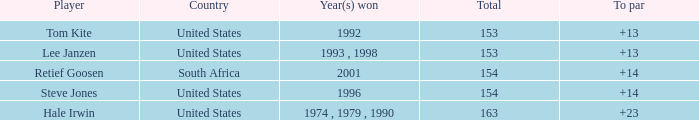What is the highest to par that is less than 153 None. 